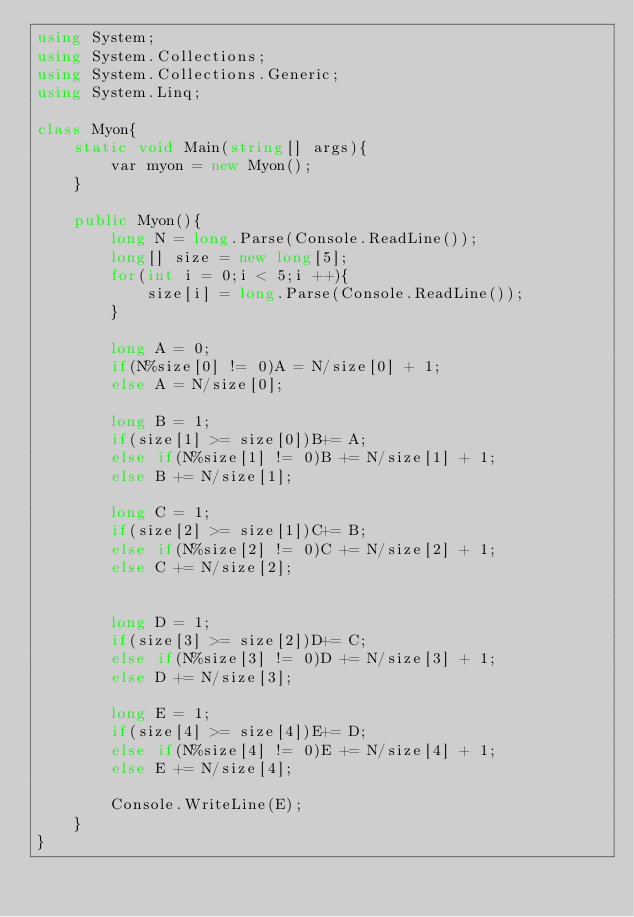Convert code to text. <code><loc_0><loc_0><loc_500><loc_500><_C#_>using System;
using System.Collections;
using System.Collections.Generic;
using System.Linq;

class Myon{
    static void Main(string[] args){
        var myon = new Myon();
    }

    public Myon(){
        long N = long.Parse(Console.ReadLine());
        long[] size = new long[5];
        for(int i = 0;i < 5;i ++){
            size[i] = long.Parse(Console.ReadLine());
        }

        long A = 0;
        if(N%size[0] != 0)A = N/size[0] + 1;
        else A = N/size[0];

        long B = 1;
        if(size[1] >= size[0])B+= A;
        else if(N%size[1] != 0)B += N/size[1] + 1;
        else B += N/size[1];

        long C = 1;
        if(size[2] >= size[1])C+= B;
        else if(N%size[2] != 0)C += N/size[2] + 1;
        else C += N/size[2];

        
        long D = 1;
        if(size[3] >= size[2])D+= C;
        else if(N%size[3] != 0)D += N/size[3] + 1;
        else D += N/size[3];
        
        long E = 1;
        if(size[4] >= size[4])E+= D;
        else if(N%size[4] != 0)E += N/size[4] + 1;
        else E += N/size[4];

        Console.WriteLine(E);
    }
}</code> 